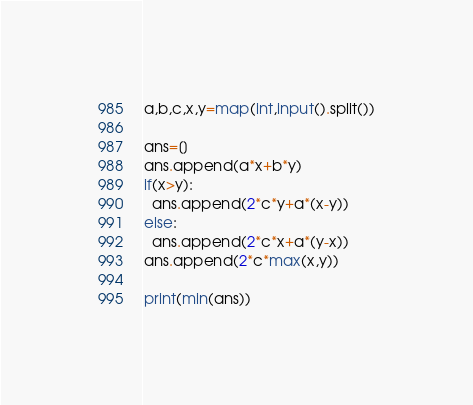<code> <loc_0><loc_0><loc_500><loc_500><_Python_>a,b,c,x,y=map(int,input().split())

ans=[]
ans.append(a*x+b*y)
if(x>y):
  ans.append(2*c*y+a*(x-y))
else:
  ans.append(2*c*x+a*(y-x))
ans.append(2*c*max(x,y))

print(min(ans))</code> 